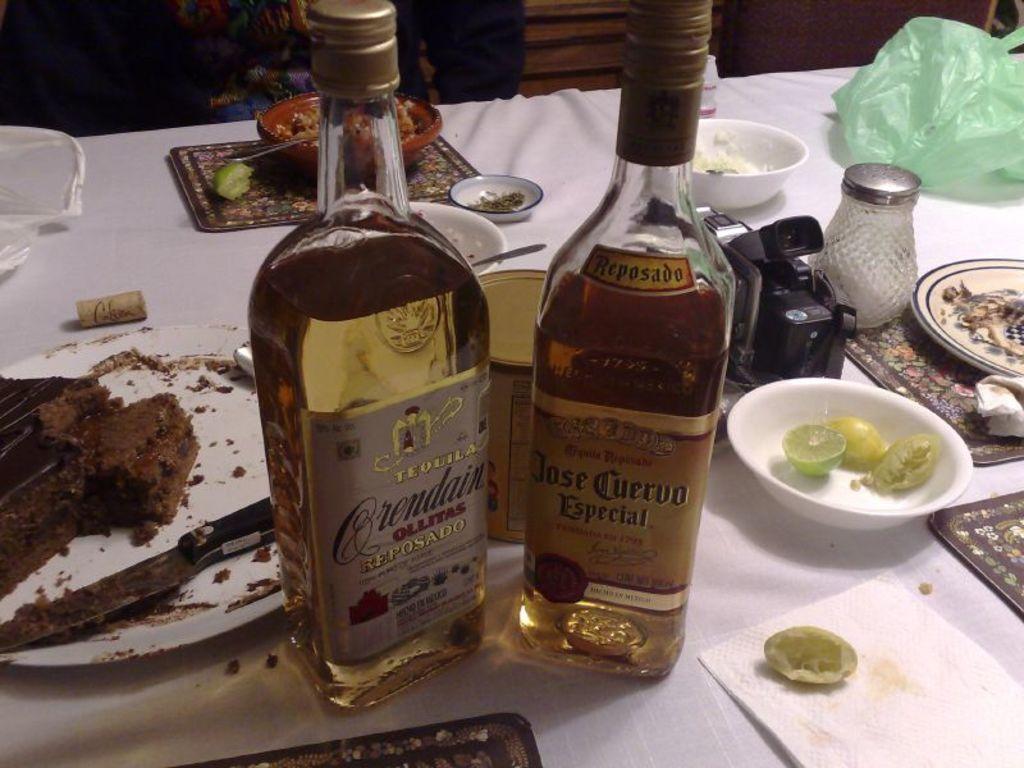Can you describe this image briefly? Here we can see a table where two wine bottles, a plate full of cake and a camera and bowls are kept on it. 